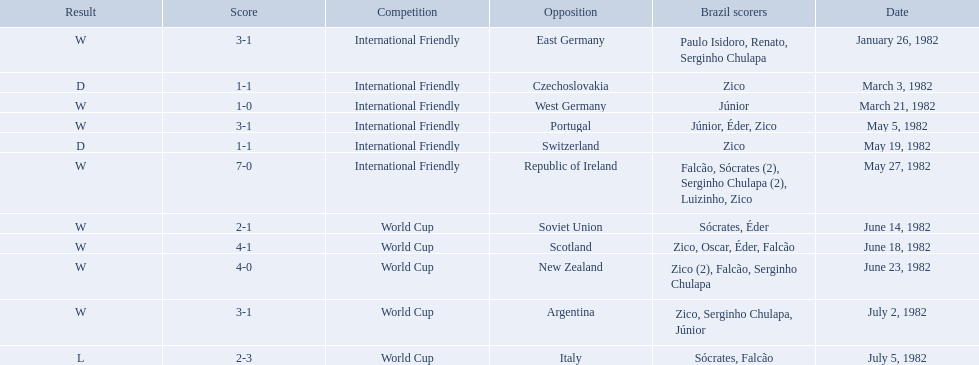What are the dates? January 26, 1982, March 3, 1982, March 21, 1982, May 5, 1982, May 19, 1982, May 27, 1982, June 14, 1982, June 18, 1982, June 23, 1982, July 2, 1982, July 5, 1982. And which date is listed first? January 26, 1982. 